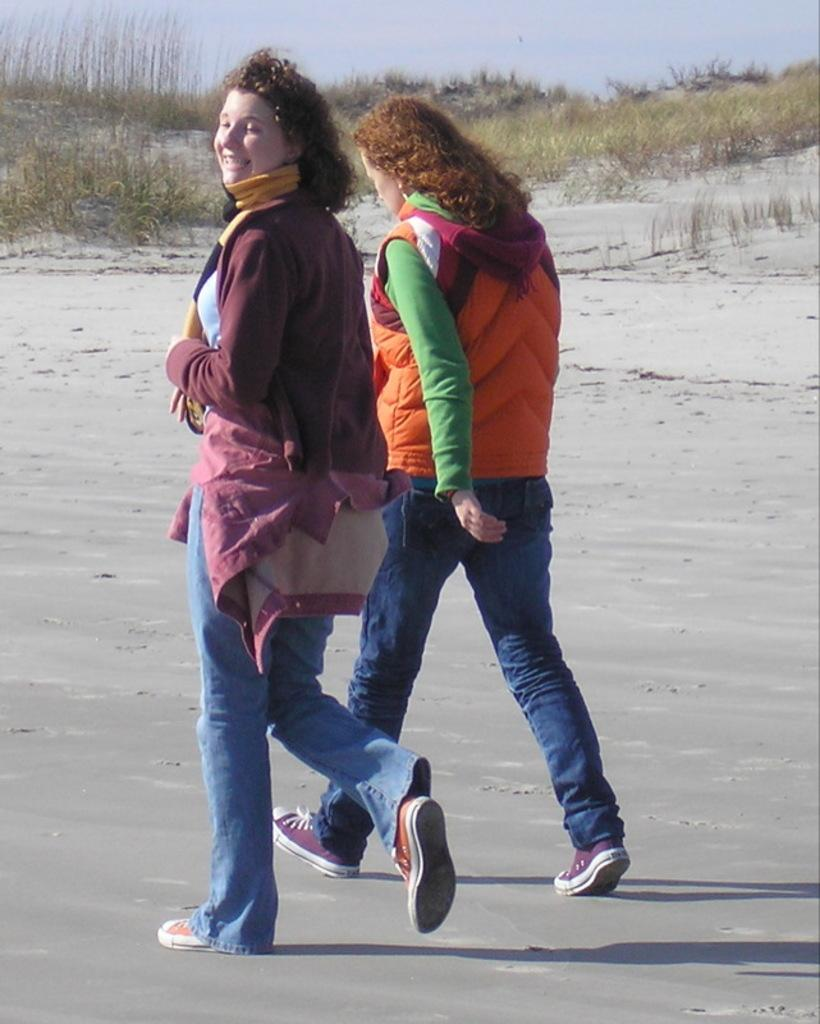How many people are in the image? There are two women in the image. What are the women doing in the image? The women are walking on a road. What can be seen at the top of the image? The sky and grass are visible at the top of the image. What type of quince is being used as a table in the image? There is no quince or table present in the image; it features two women walking on a road. 